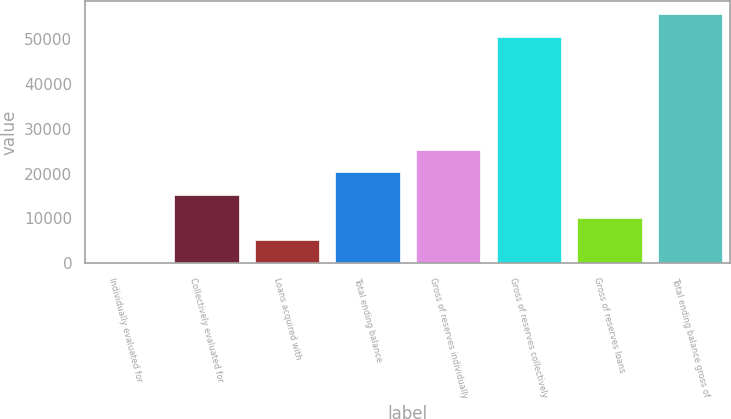Convert chart to OTSL. <chart><loc_0><loc_0><loc_500><loc_500><bar_chart><fcel>Individually evaluated for<fcel>Collectively evaluated for<fcel>Loans acquired with<fcel>Total ending balance<fcel>Gross of reserves individually<fcel>Gross of reserves collectively<fcel>Gross of reserves loans<fcel>Total ending balance gross of<nl><fcel>1<fcel>15202<fcel>5068<fcel>20269<fcel>25336<fcel>50550<fcel>10135<fcel>55617<nl></chart> 